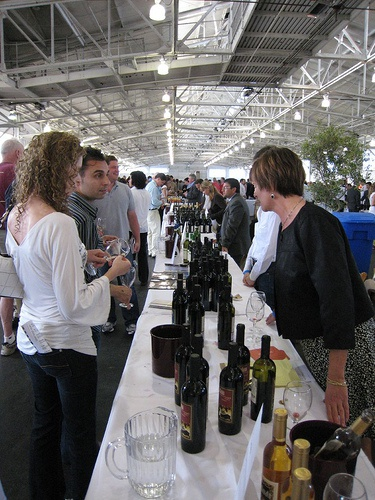Describe the objects in this image and their specific colors. I can see dining table in black, darkgray, lightgray, and gray tones, people in black, darkgray, lavender, and gray tones, people in black, maroon, and gray tones, cup in black, darkgray, lightgray, and gray tones, and potted plant in black, gray, darkgreen, and darkgray tones in this image. 